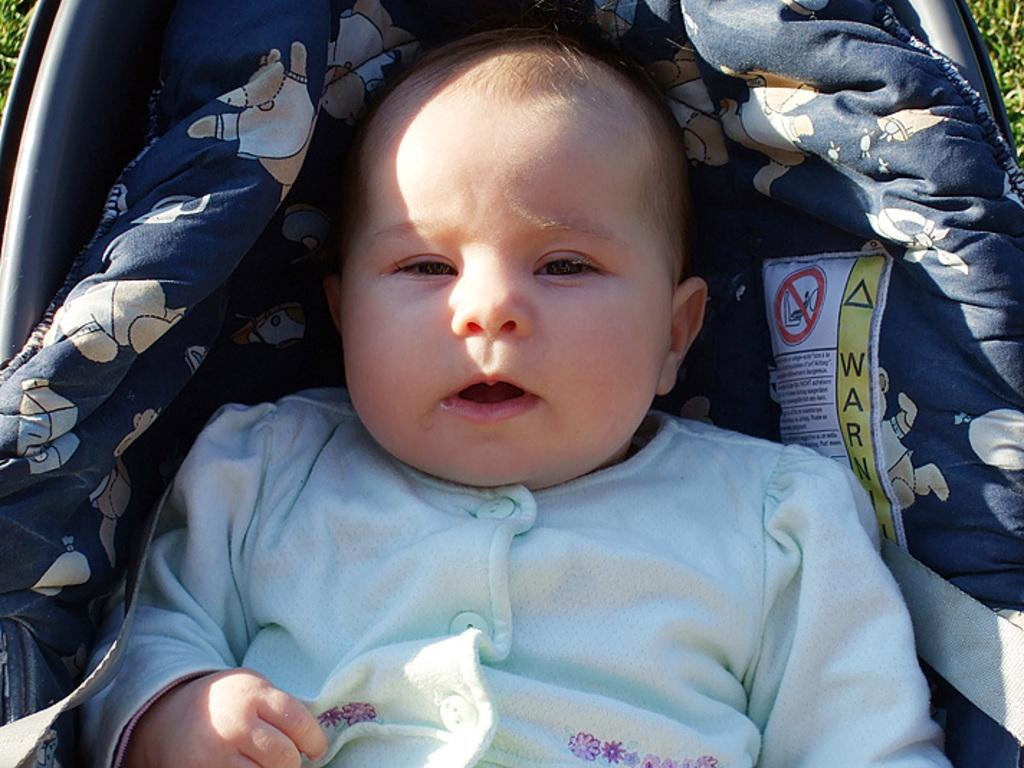What is the main subject of the image? The main subject of the image is a baby. Where is the baby located in the image? The baby is in a stroller. What type of caption is written below the baby in the image? There is no caption written below the baby in the image. Are there any police officers present in the image? There is no mention of police officers in the image. What type of prose is being recited by the baby in the image? The baby is not reciting any prose in the image. 